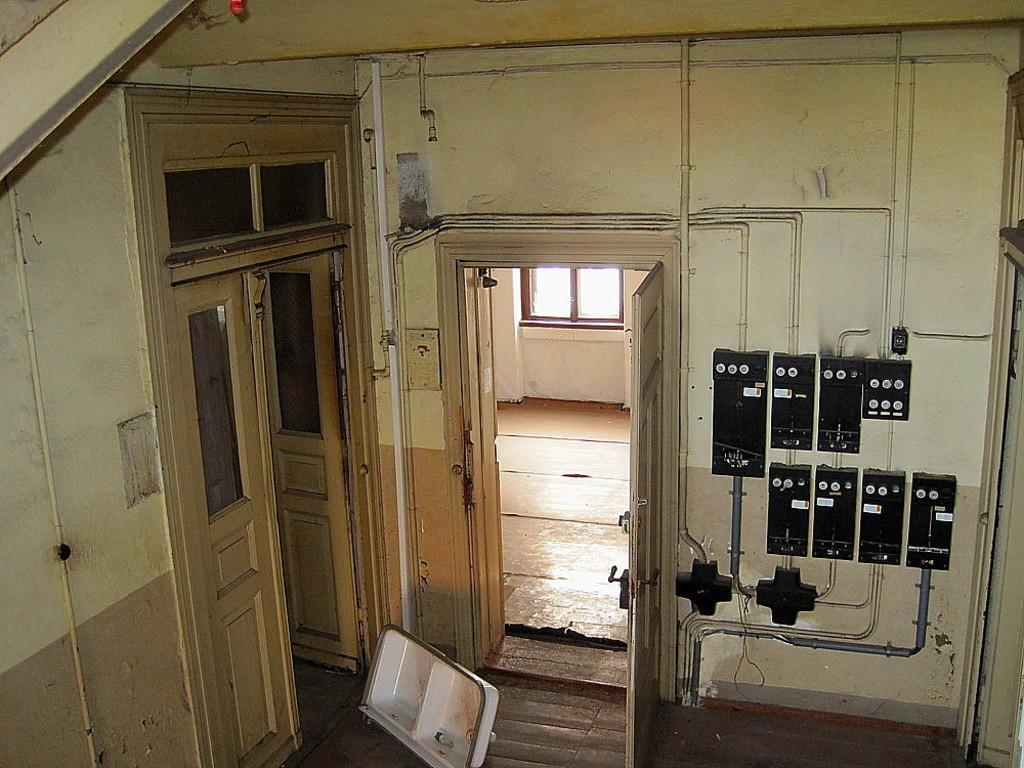Can you describe this image briefly? This is an inside view of a room. On the right side there are few electrical boxes attached to the wall. On the left side, I can see the doors. At the bottom there is a white color object placed on the ground. In the background there is a window. 